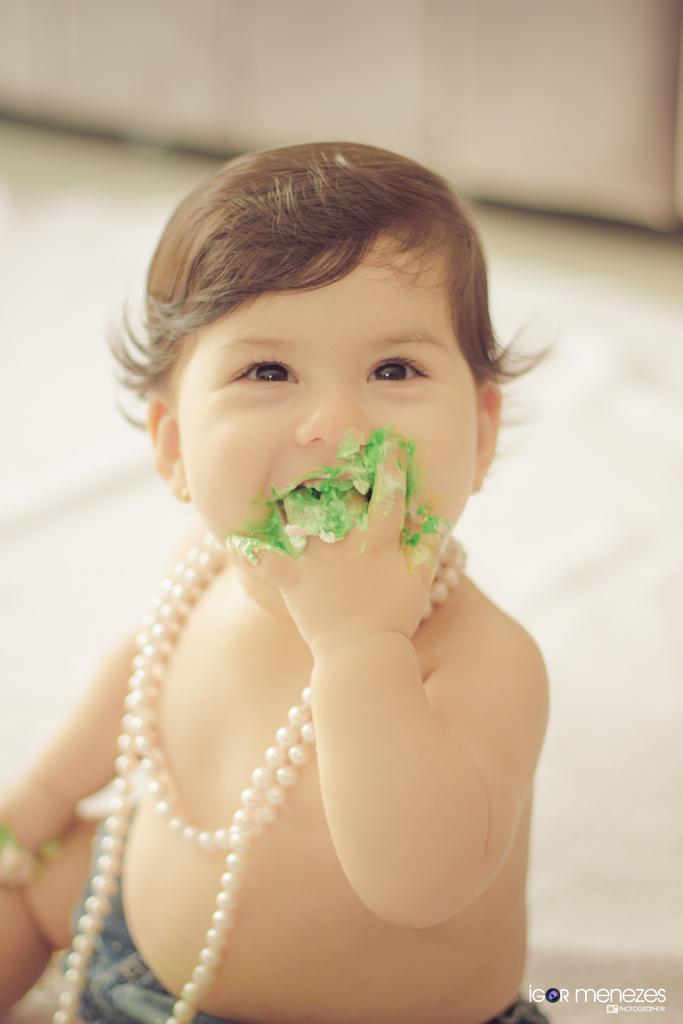Can you describe this image briefly? In this image in the front there is person smiling and at the bottom right of the image there is some text which is visible and the background is blurry. 